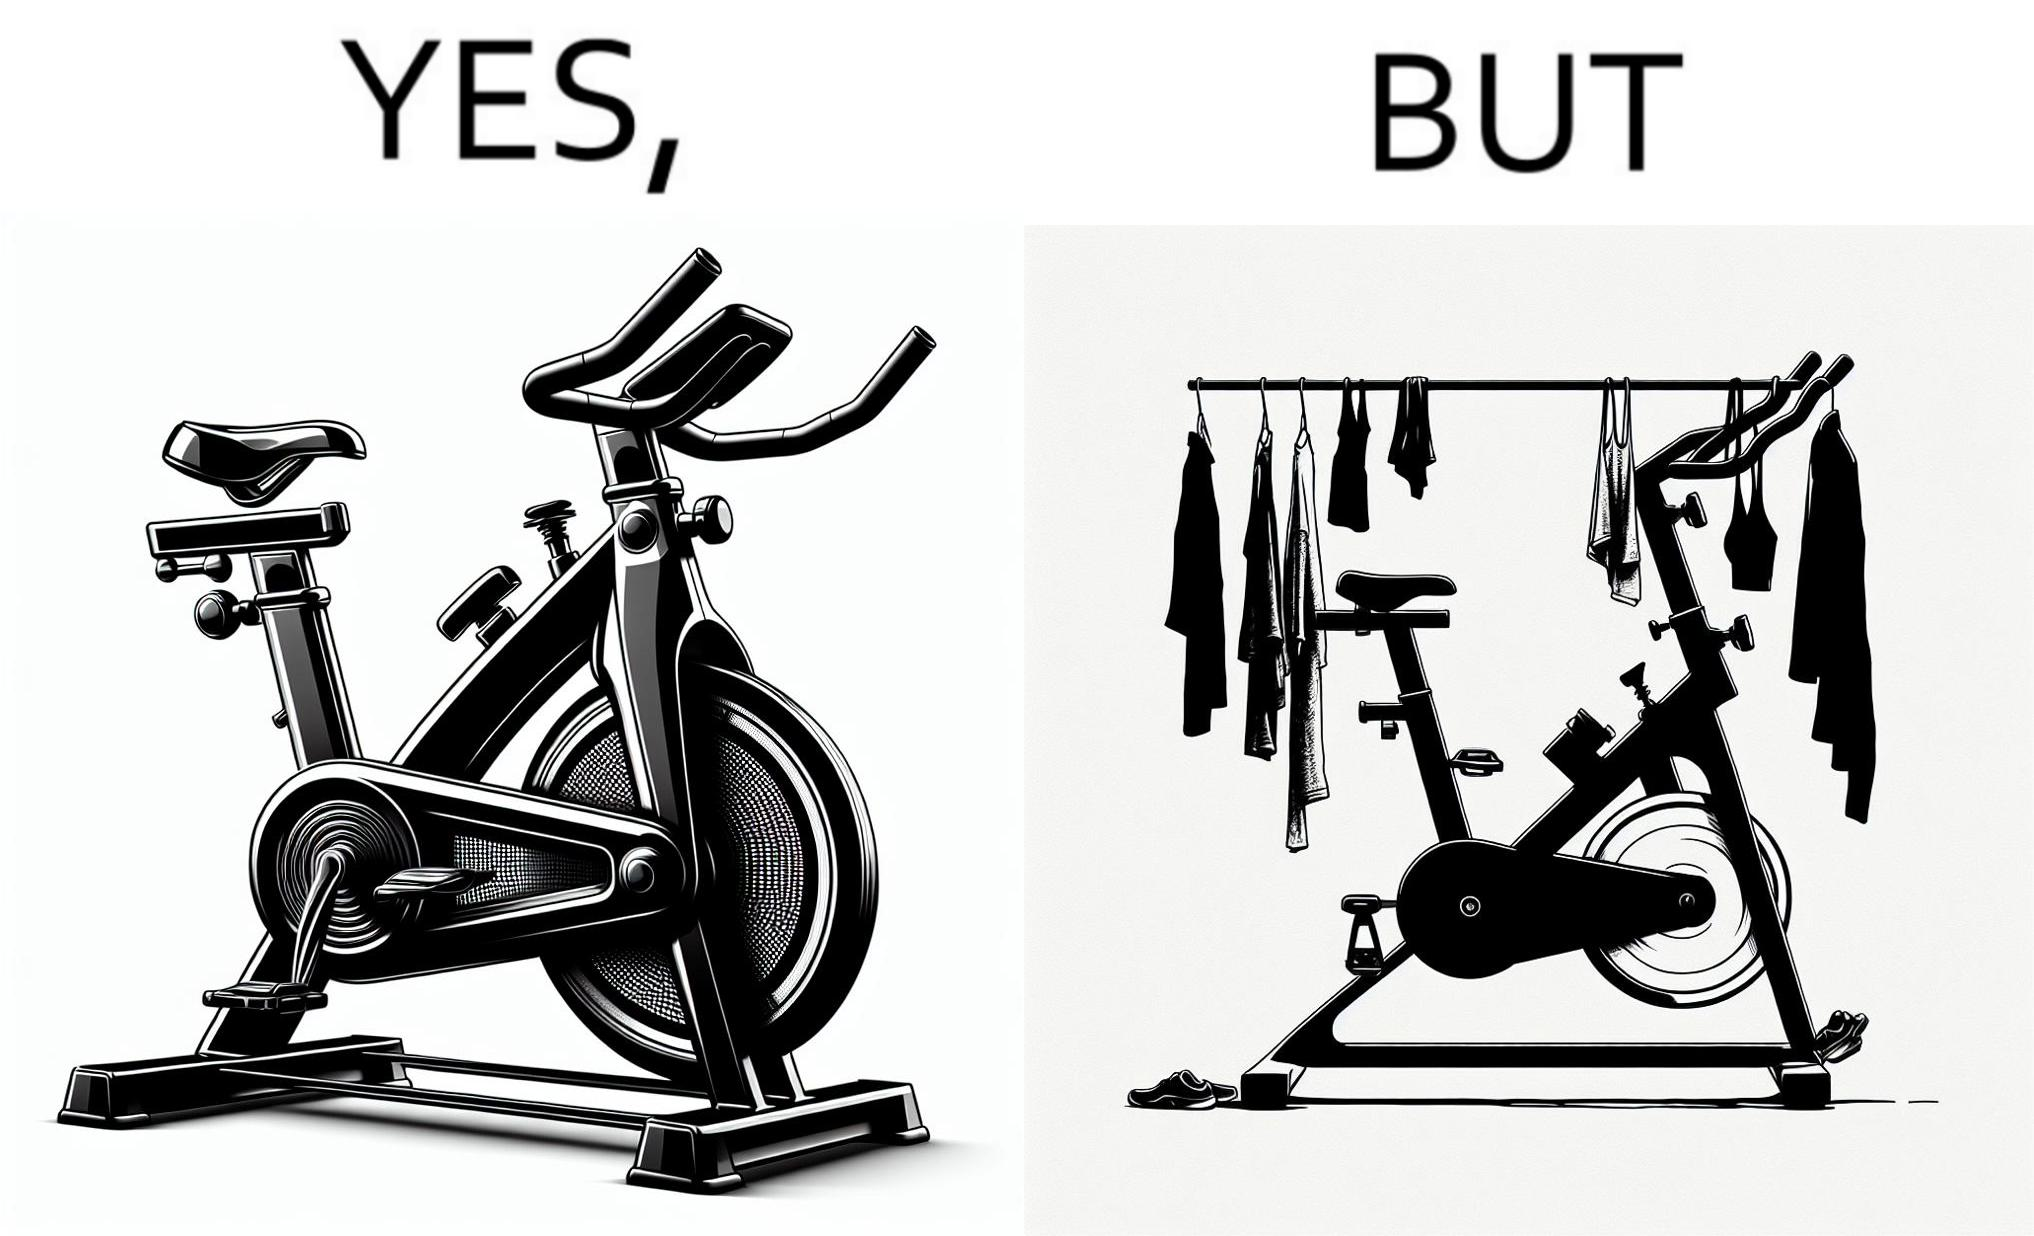Describe what you see in this image. The images are funny since they show an exercise bike has been bought but is not being used for its purpose, that is, exercising. It is rather being used to hang clothes, bags and other items 